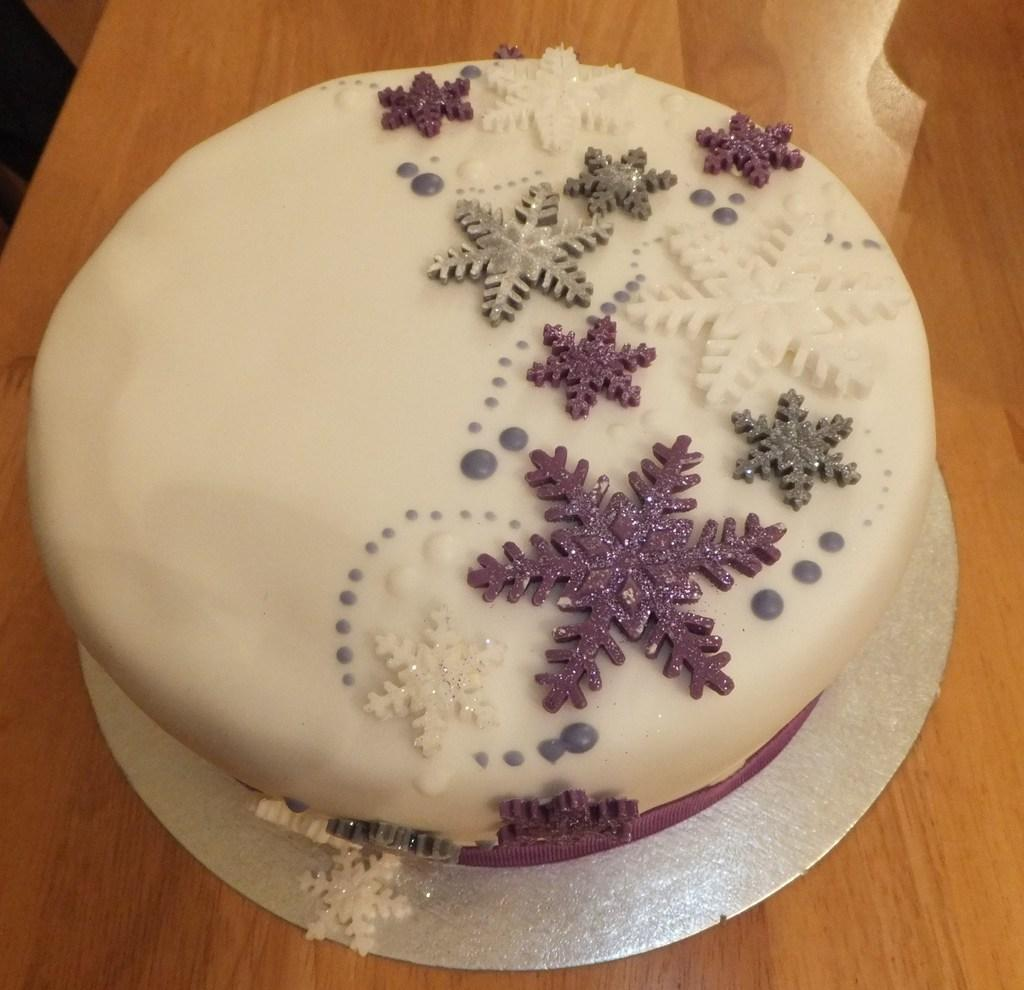What is the main subject of the image? There is a cake in the image. Where is the cake located? The cake is on a wooden table. What type of education does the cake have in the image? The cake does not have any education, as it is an inanimate object and cannot receive education. 